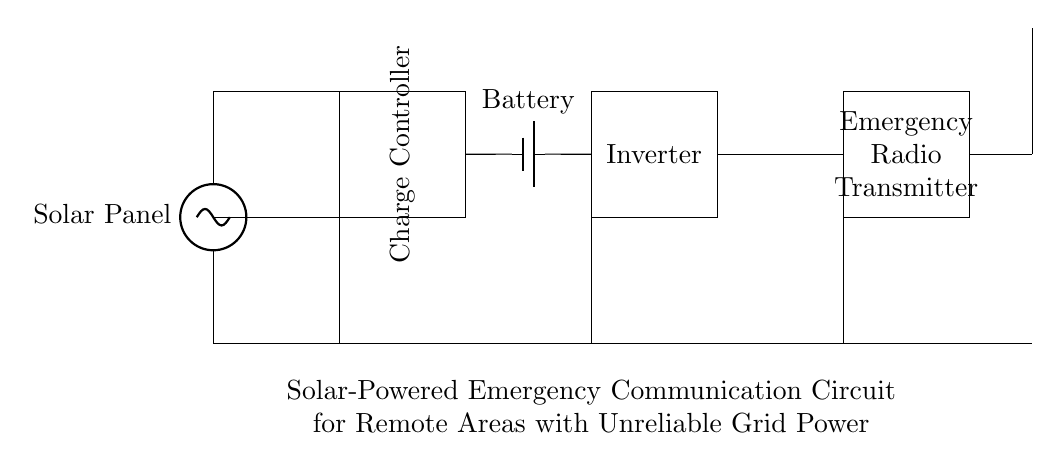What is the first component in the circuit? The first component is the solar panel, which is drawn at the very beginning of the circuit on the left side.
Answer: Solar Panel What does the charge controller regulate? The charge controller regulates the charging process of the battery, ensuring it does not get overcharged or overly discharged.
Answer: Battery charging What is the voltage source of this circuit? The voltage source in this circuit is the solar panel, which converts sunlight into electrical energy.
Answer: Solar Panel How many main components are involved in this emergency communication circuit? Counting the solar panel, charge controller, battery, inverter, radio transmitter, and antenna, there are six main components involved.
Answer: Six What is the role of the inverter in this circuit? The inverter converts the direct current from the battery into alternating current, which is necessary for the radio transmitter to function properly.
Answer: Converts DC to AC Why is the antenna included in the circuit? The antenna is included for transmitting radio signals, enabling communication with other devices or stations in emergency situations.
Answer: Transmission What would happen if the battery were removed from the circuit? If the battery were removed, the system would lack a storage mechanism for the solar energy, making it unable to supply power during non-sunlight hours, potentially leading to communication failures.
Answer: No power storage 